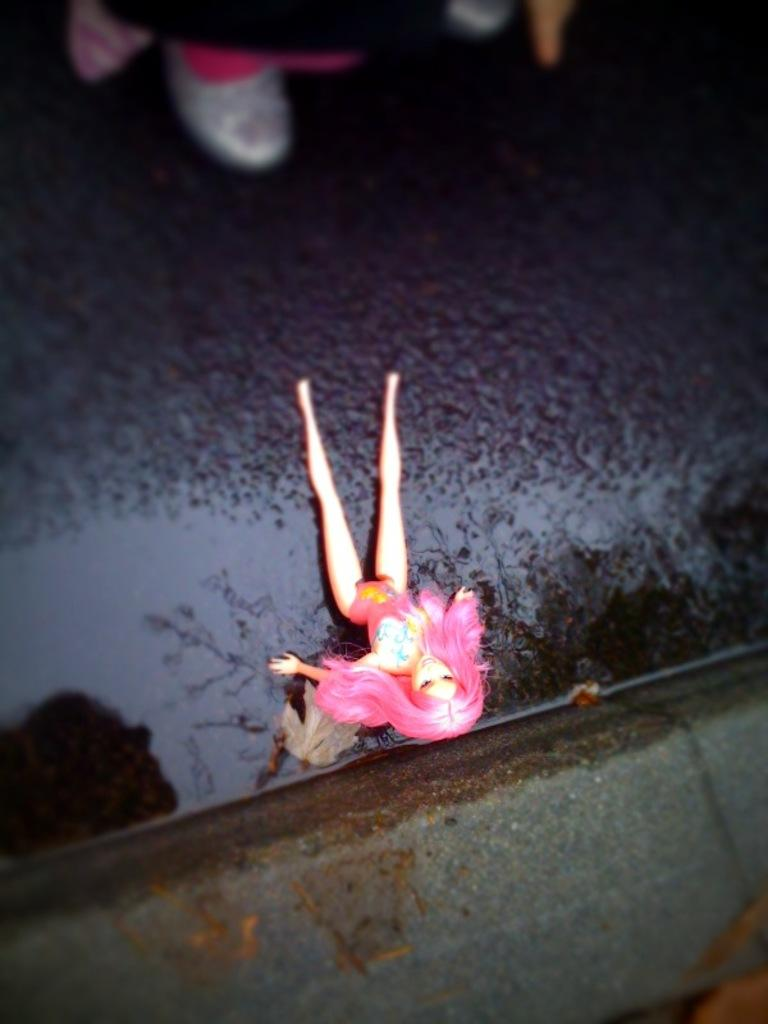What is the main subject in the center of the image? There is a doll in the center of the image. Where is the doll located? The doll is on the road. Can you describe anything else visible in the image? There is a person visible in the background of the image. Can you tell me how many times the lamp has been touched by the doll in the image? There is no lamp present in the image, so it is not possible to determine how many times the doll has touched it. 